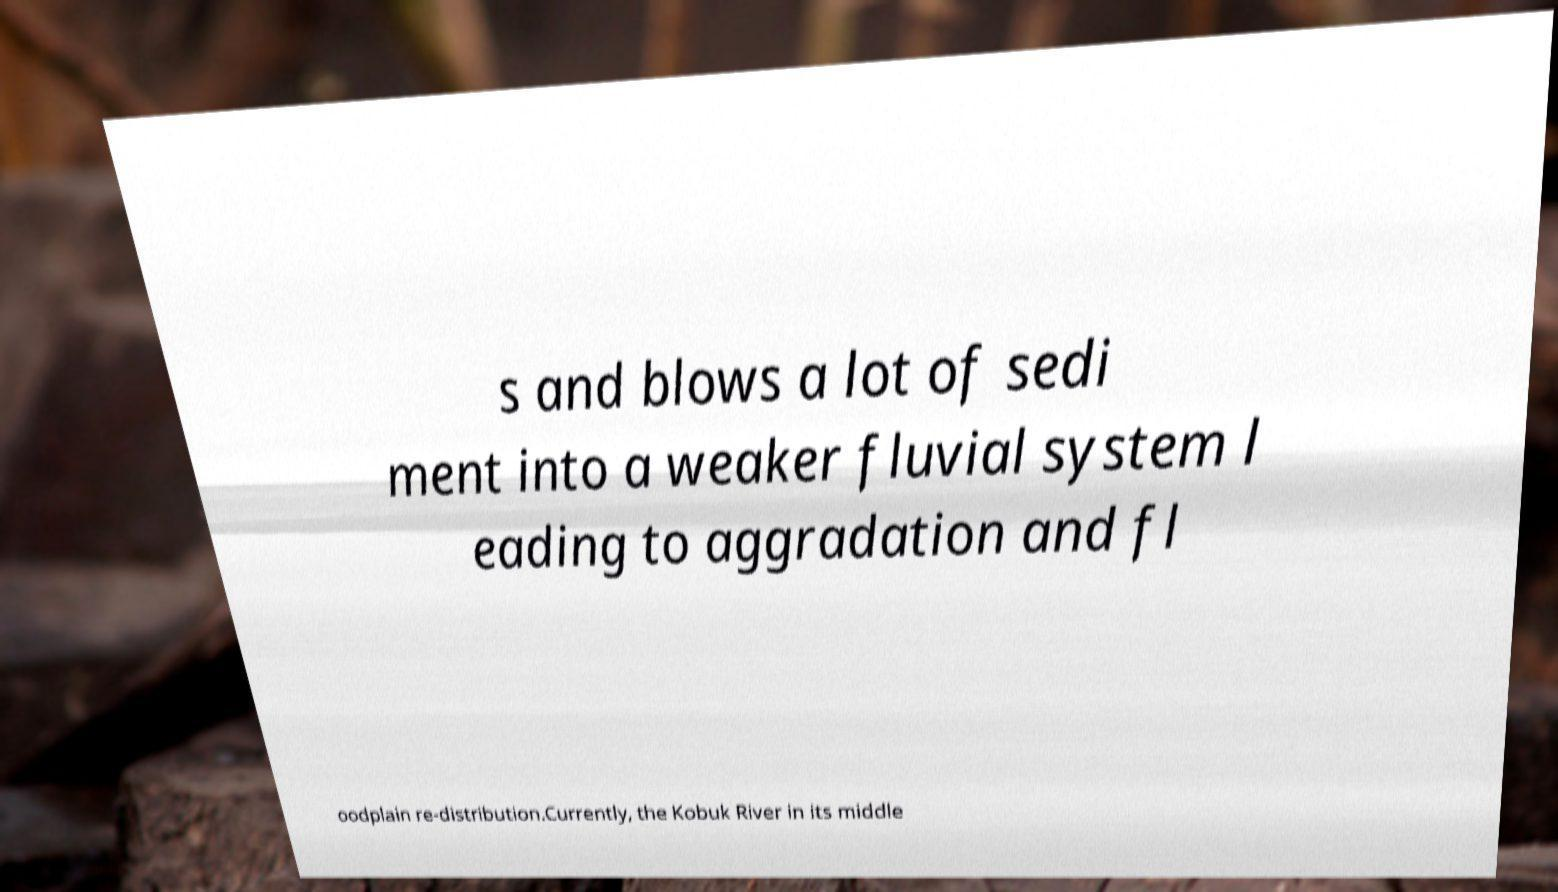Please read and relay the text visible in this image. What does it say? s and blows a lot of sedi ment into a weaker fluvial system l eading to aggradation and fl oodplain re-distribution.Currently, the Kobuk River in its middle 